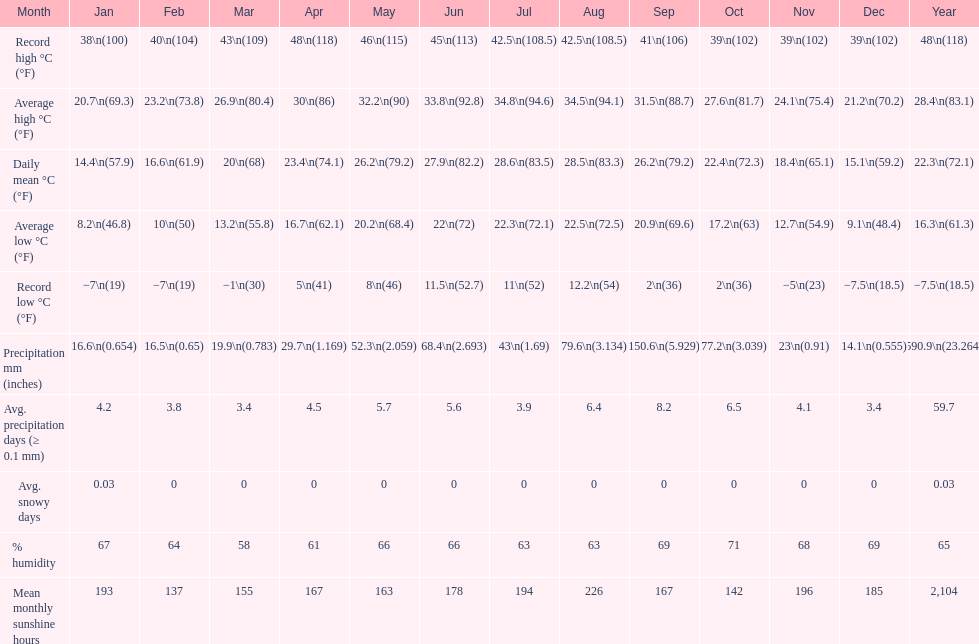Was there more precipitation in march or april? April. 